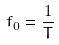Convert formula to latex. <formula><loc_0><loc_0><loc_500><loc_500>f _ { 0 } = \frac { 1 } { T }</formula> 